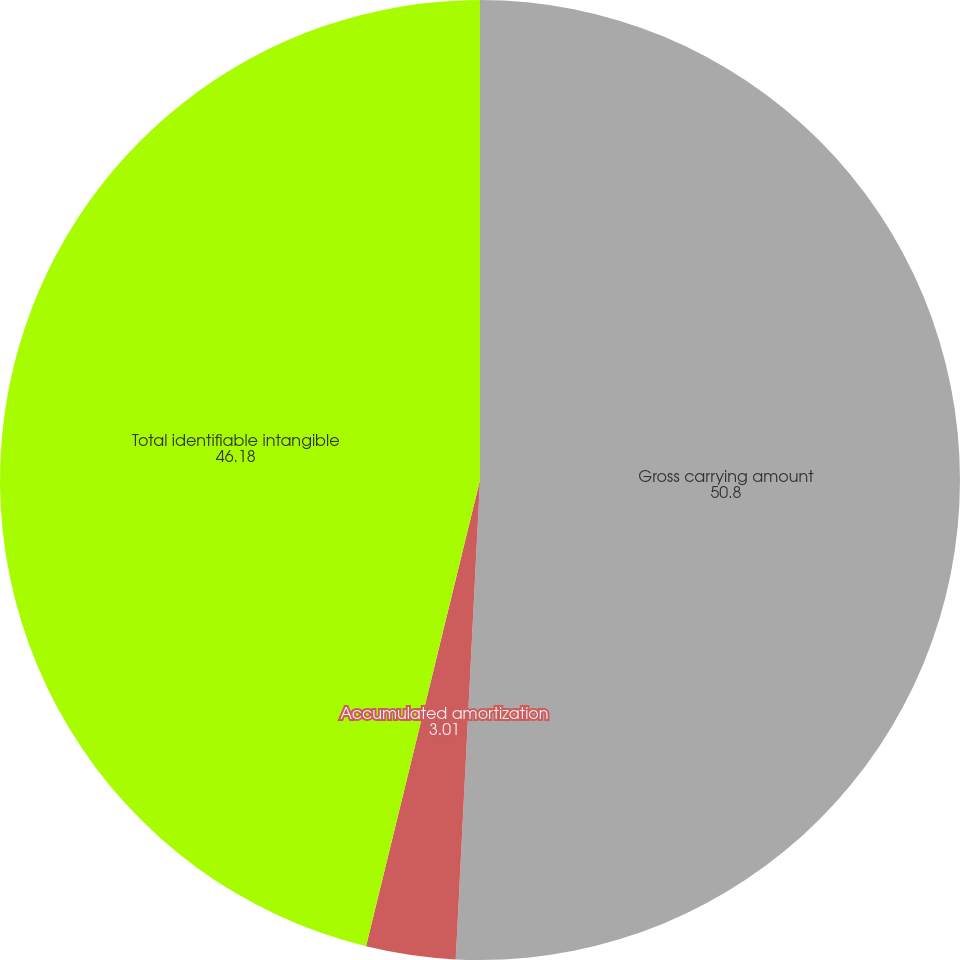Convert chart. <chart><loc_0><loc_0><loc_500><loc_500><pie_chart><fcel>Gross carrying amount<fcel>Accumulated amortization<fcel>Total identifiable intangible<nl><fcel>50.8%<fcel>3.01%<fcel>46.18%<nl></chart> 